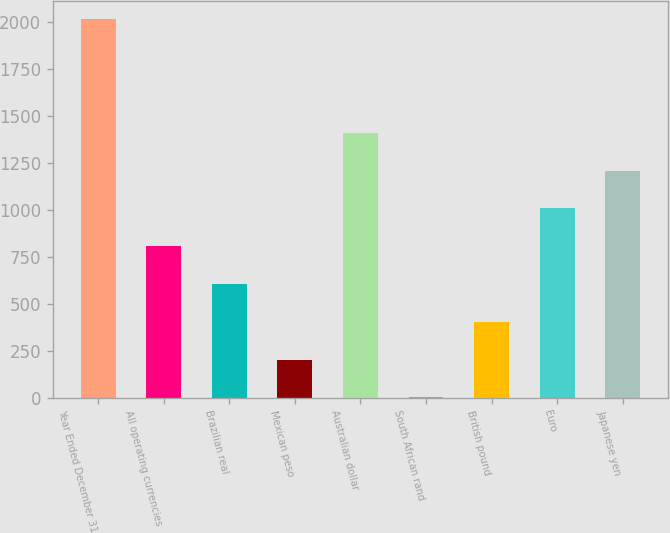Convert chart to OTSL. <chart><loc_0><loc_0><loc_500><loc_500><bar_chart><fcel>Year Ended December 31<fcel>All operating currencies<fcel>Brazilian real<fcel>Mexican peso<fcel>Australian dollar<fcel>South African rand<fcel>British pound<fcel>Euro<fcel>Japanese yen<nl><fcel>2011<fcel>805<fcel>604<fcel>202<fcel>1408<fcel>1<fcel>403<fcel>1006<fcel>1207<nl></chart> 